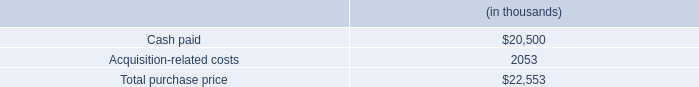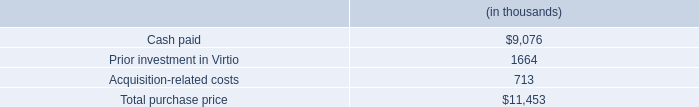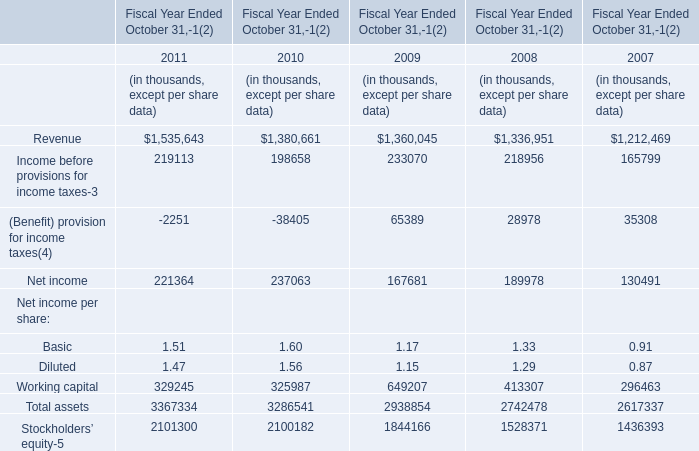what is the percentage of customer relationships among the total intangible assets? 
Computations: (0.4 / 2.5)
Answer: 0.16. 